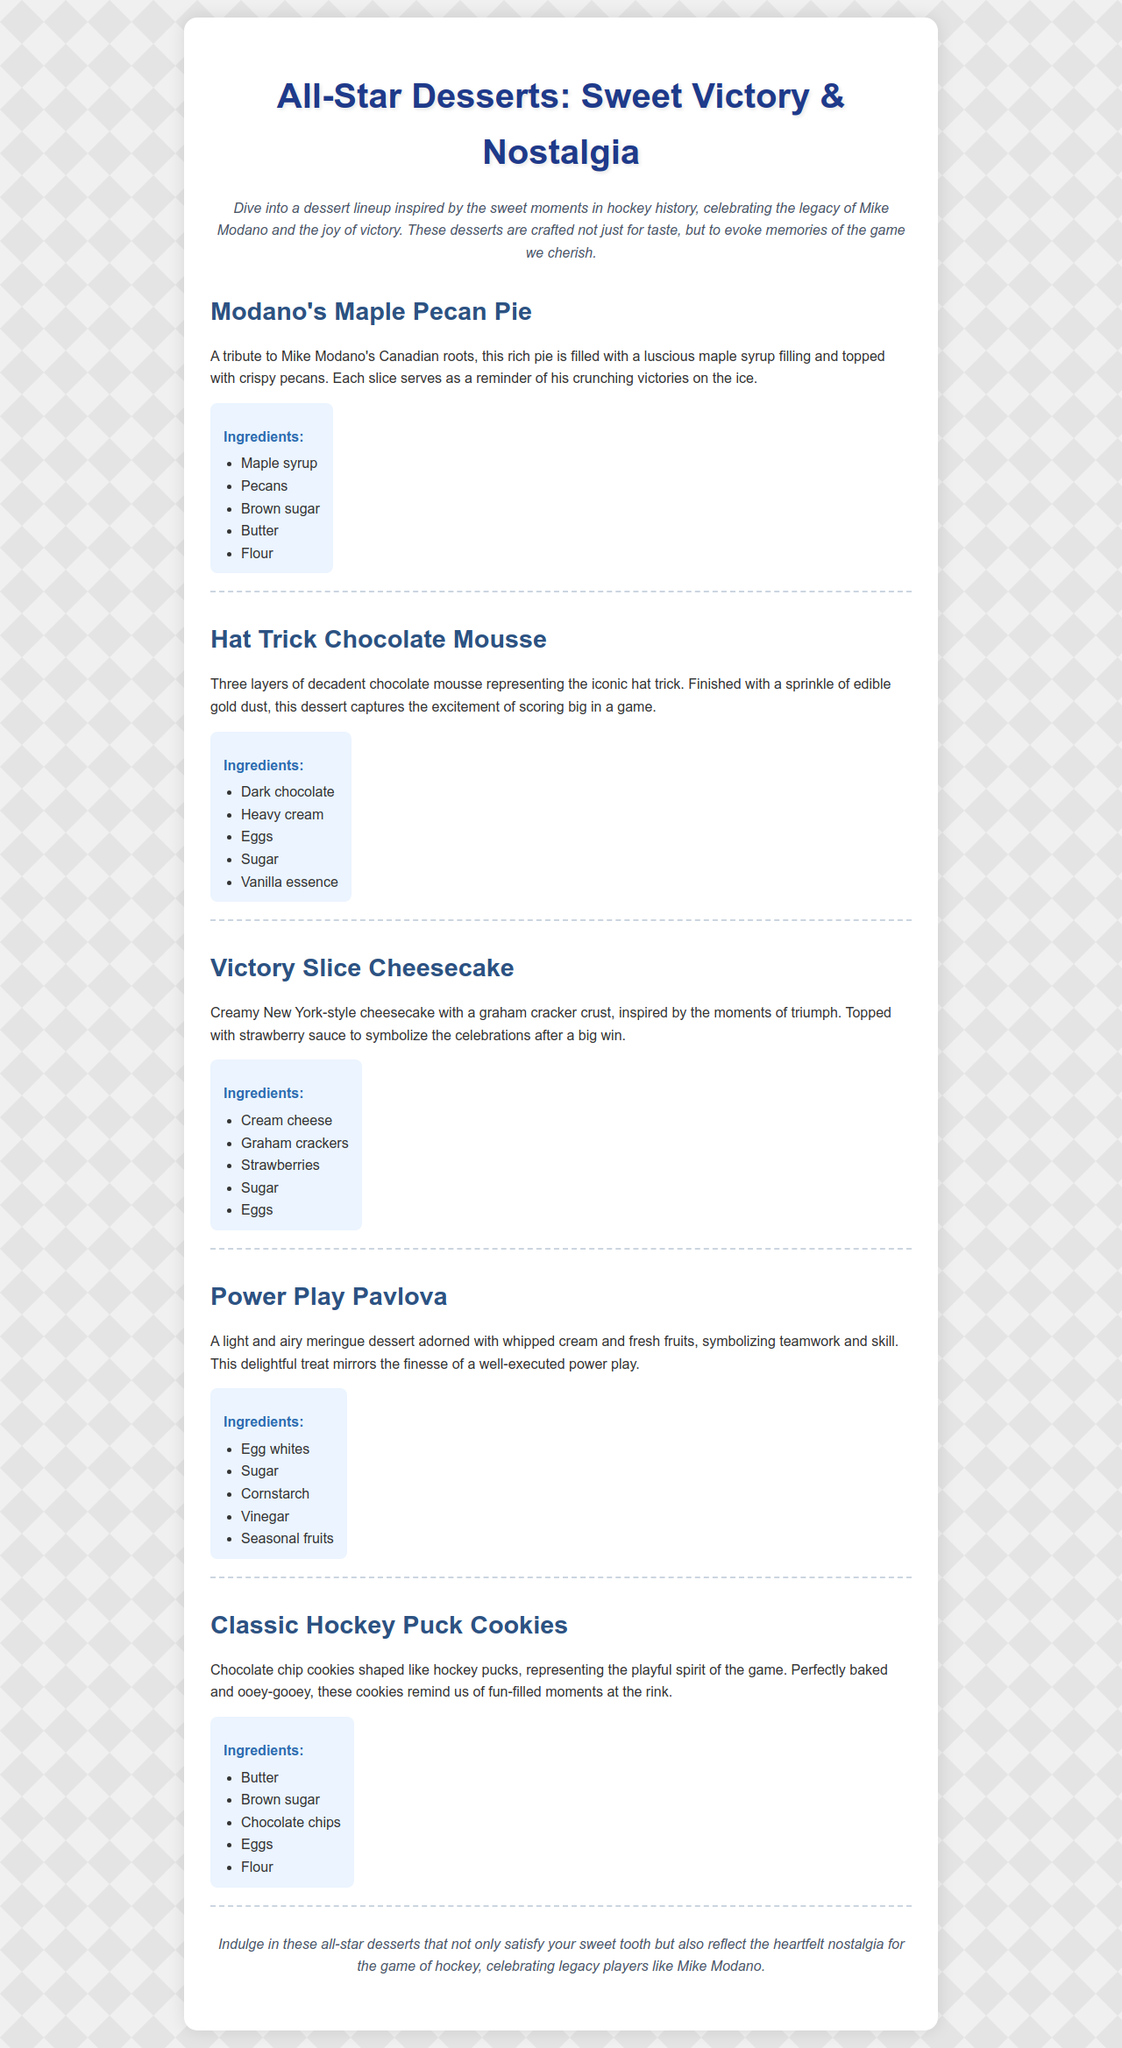What is the first dessert listed on the menu? The first dessert mentioned is "Modano's Maple Pecan Pie".
Answer: Modano's Maple Pecan Pie What type of pie is featured in the menu? The dessert features a "rich pie" filled with maple syrup, specifically "Modano's Maple Pecan Pie".
Answer: Maple Pecan Pie How many layers does the Hat Trick Chocolate Mousse have? The description states that the dessert has "Three layers" of mousse.
Answer: Three layers What is the main flavor of the Victory Slice Cheesecake? The dessert is described as a "creamy New York-style cheesecake".
Answer: Cheesecake Which dessert is inspired by teamwork? The "Power Play Pavlova" is described as reflecting "teamwork and skill".
Answer: Power Play Pavlova What sweet ingredient tops the Victory Slice Cheesecake? The cheesecake is topped with "strawberry sauce".
Answer: Strawberry sauce What type of cookies are shaped like hockey pucks? The menu lists "Chocolate chip cookies" shaped as hockey pucks.
Answer: Chocolate chip cookies What ingredient is common in both Modano's Maple Pecan Pie and Classic Hockey Puck Cookies? Both desserts contain "Butter" as an ingredient.
Answer: Butter What festive element does the Hat Trick Chocolate Mousse finish with? It is finished with a "sprinkle of edible gold dust".
Answer: Edible gold dust 